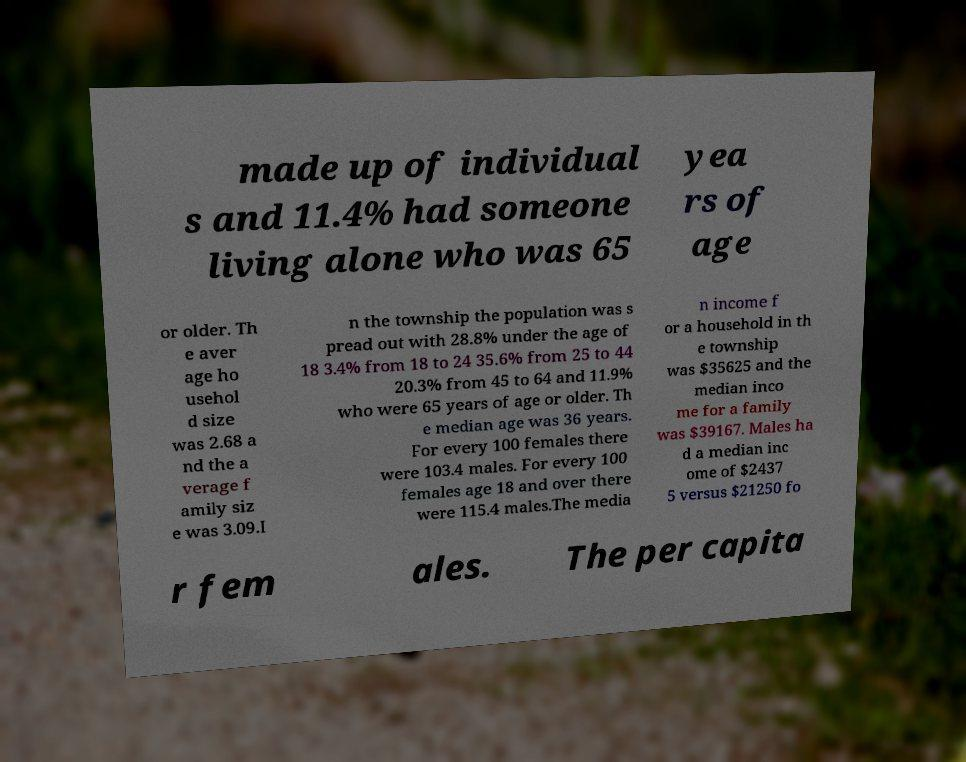Please identify and transcribe the text found in this image. made up of individual s and 11.4% had someone living alone who was 65 yea rs of age or older. Th e aver age ho usehol d size was 2.68 a nd the a verage f amily siz e was 3.09.I n the township the population was s pread out with 28.8% under the age of 18 3.4% from 18 to 24 35.6% from 25 to 44 20.3% from 45 to 64 and 11.9% who were 65 years of age or older. Th e median age was 36 years. For every 100 females there were 103.4 males. For every 100 females age 18 and over there were 115.4 males.The media n income f or a household in th e township was $35625 and the median inco me for a family was $39167. Males ha d a median inc ome of $2437 5 versus $21250 fo r fem ales. The per capita 